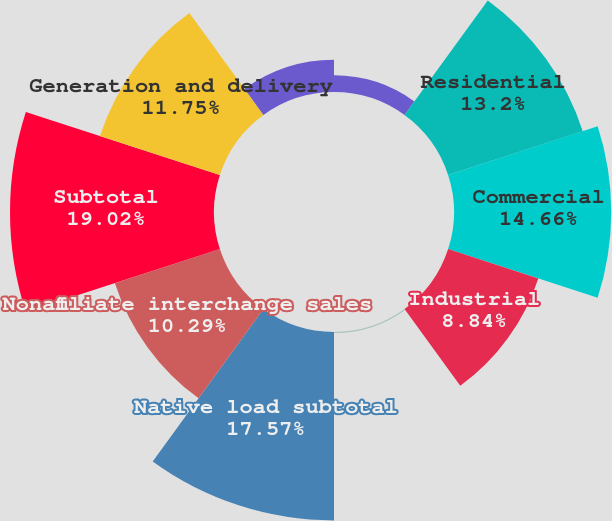<chart> <loc_0><loc_0><loc_500><loc_500><pie_chart><fcel>Electric Operating Statistics<fcel>Residential<fcel>Commercial<fcel>Industrial<fcel>Other<fcel>Native load subtotal<fcel>Nonaffiliate interchange sales<fcel>Subtotal<fcel>Generation and delivery<fcel>Delivery service only<nl><fcel>1.56%<fcel>13.2%<fcel>14.66%<fcel>8.84%<fcel>0.1%<fcel>17.57%<fcel>10.29%<fcel>19.02%<fcel>11.75%<fcel>3.01%<nl></chart> 